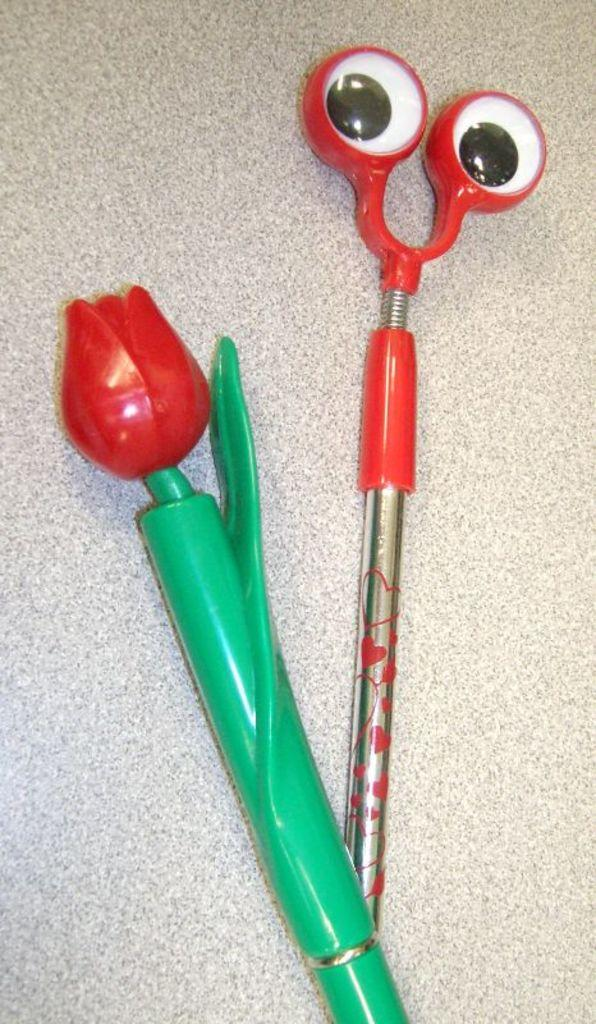What type of objects are in the image? There are toy pens in the image. Where are the toy pens located? The toy pens are on a table. What type of produce is visible in the image? There is no produce present in the image; it features toy pens on a table. What type of calculator is being used in the image? There is no calculator present in the image. 